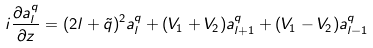<formula> <loc_0><loc_0><loc_500><loc_500>i \frac { \partial a ^ { q } _ { l } } { \partial z } = ( 2 l + \tilde { q } ) ^ { 2 } a ^ { q } _ { l } + ( V _ { 1 } + V _ { 2 } ) a ^ { q } _ { l + 1 } + ( V _ { 1 } - V _ { 2 } ) a ^ { q } _ { l - 1 }</formula> 